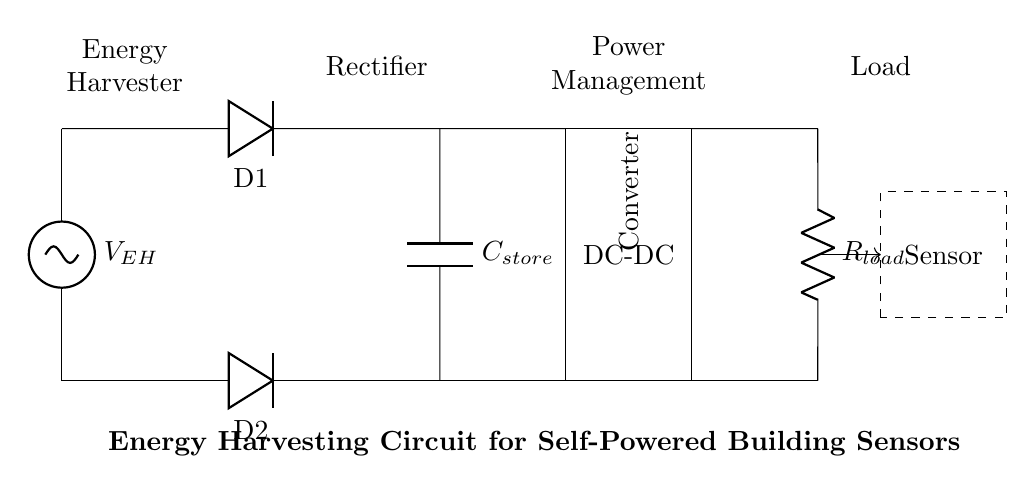What is the main function of the energy harvester? The energy harvester is designed to convert ambient energy into electrical energy. This is indicated by the label near the voltage source, showing it as the source of energy in the circuit.
Answer: Convert ambient energy What components are used in the rectification process? The rectification process uses two diodes, labeled D1 and D2 in the circuit, which allow current to flow in one direction only, thereby converting AC to DC.
Answer: Two diodes What is the role of the capacitor in this circuit? The capacitor, labeled C_store, stores energy from the rectified output, providing a stable voltage supply to the load when required. This is essential for a self-powered system.
Answer: Energy storage What type of converter is implemented in this circuit? The circuit includes a DC-DC converter, which is clearly labeled and used to adjust the voltage level for the load. This is fundamental for ensuring the load operates at appropriate voltage levels.
Answer: DC-DC Converter What is the representation of the dashed box in the diagram? The dashed box contains the sensor, indicating that it is a load that will be powered by the energy harvested and stored, essential for monitoring or control functions in a building.
Answer: Sensor 